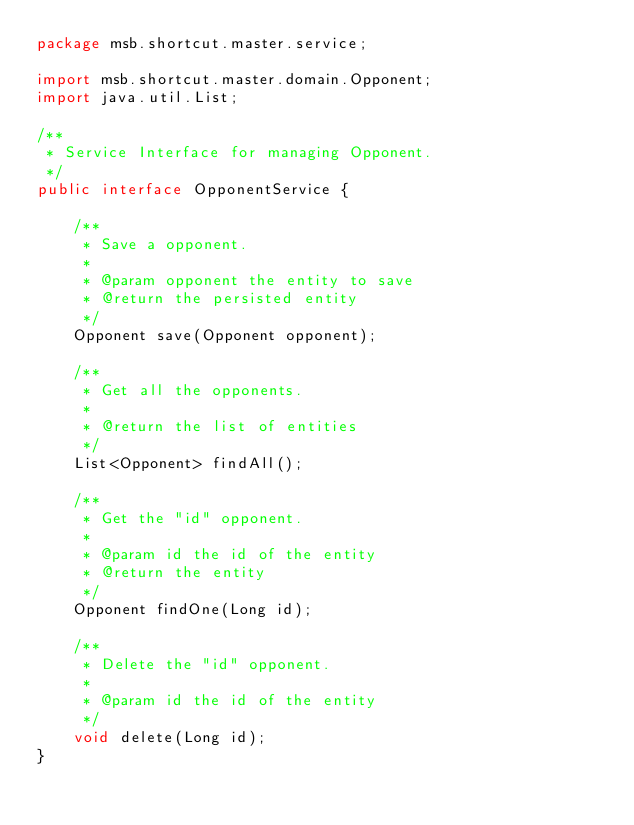Convert code to text. <code><loc_0><loc_0><loc_500><loc_500><_Java_>package msb.shortcut.master.service;

import msb.shortcut.master.domain.Opponent;
import java.util.List;

/**
 * Service Interface for managing Opponent.
 */
public interface OpponentService {

    /**
     * Save a opponent.
     *
     * @param opponent the entity to save
     * @return the persisted entity
     */
    Opponent save(Opponent opponent);

    /**
     * Get all the opponents.
     *
     * @return the list of entities
     */
    List<Opponent> findAll();

    /**
     * Get the "id" opponent.
     *
     * @param id the id of the entity
     * @return the entity
     */
    Opponent findOne(Long id);

    /**
     * Delete the "id" opponent.
     *
     * @param id the id of the entity
     */
    void delete(Long id);
}
</code> 